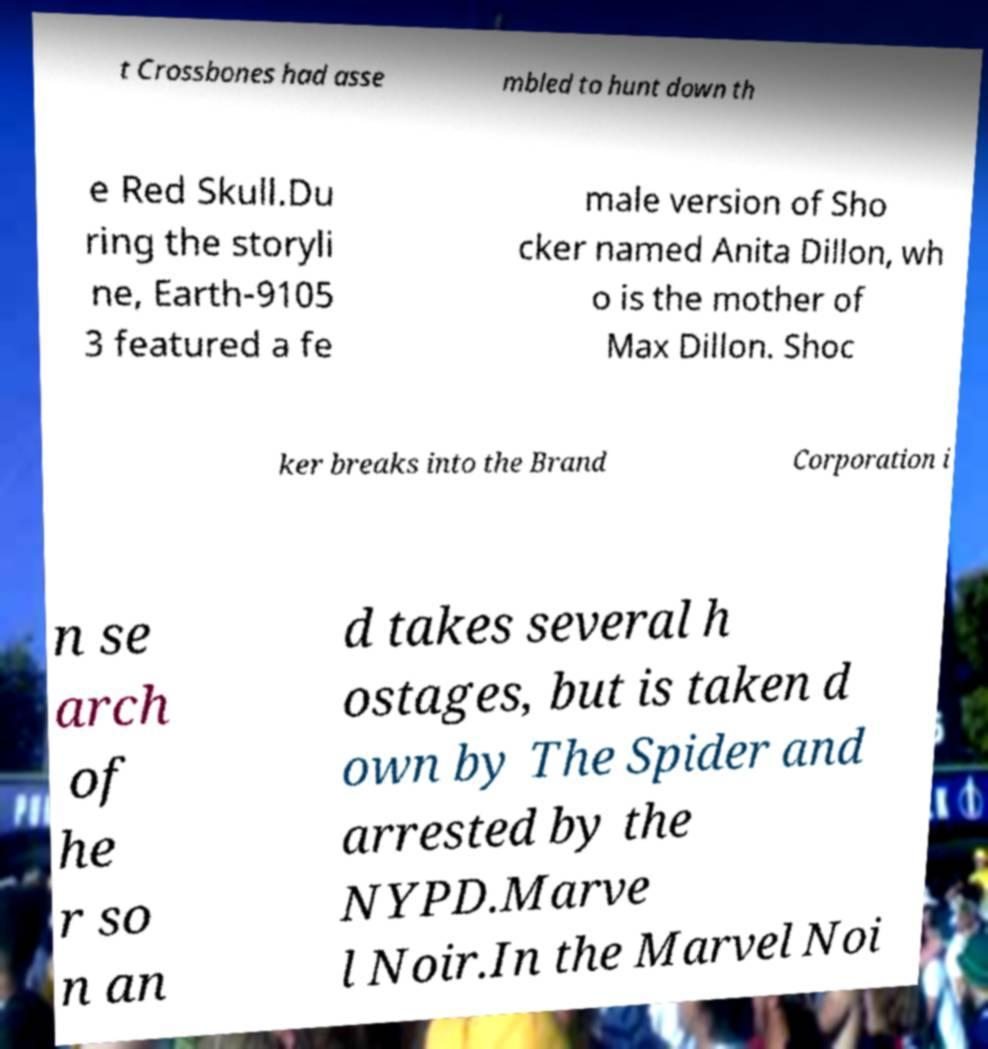Could you assist in decoding the text presented in this image and type it out clearly? t Crossbones had asse mbled to hunt down th e Red Skull.Du ring the storyli ne, Earth-9105 3 featured a fe male version of Sho cker named Anita Dillon, wh o is the mother of Max Dillon. Shoc ker breaks into the Brand Corporation i n se arch of he r so n an d takes several h ostages, but is taken d own by The Spider and arrested by the NYPD.Marve l Noir.In the Marvel Noi 